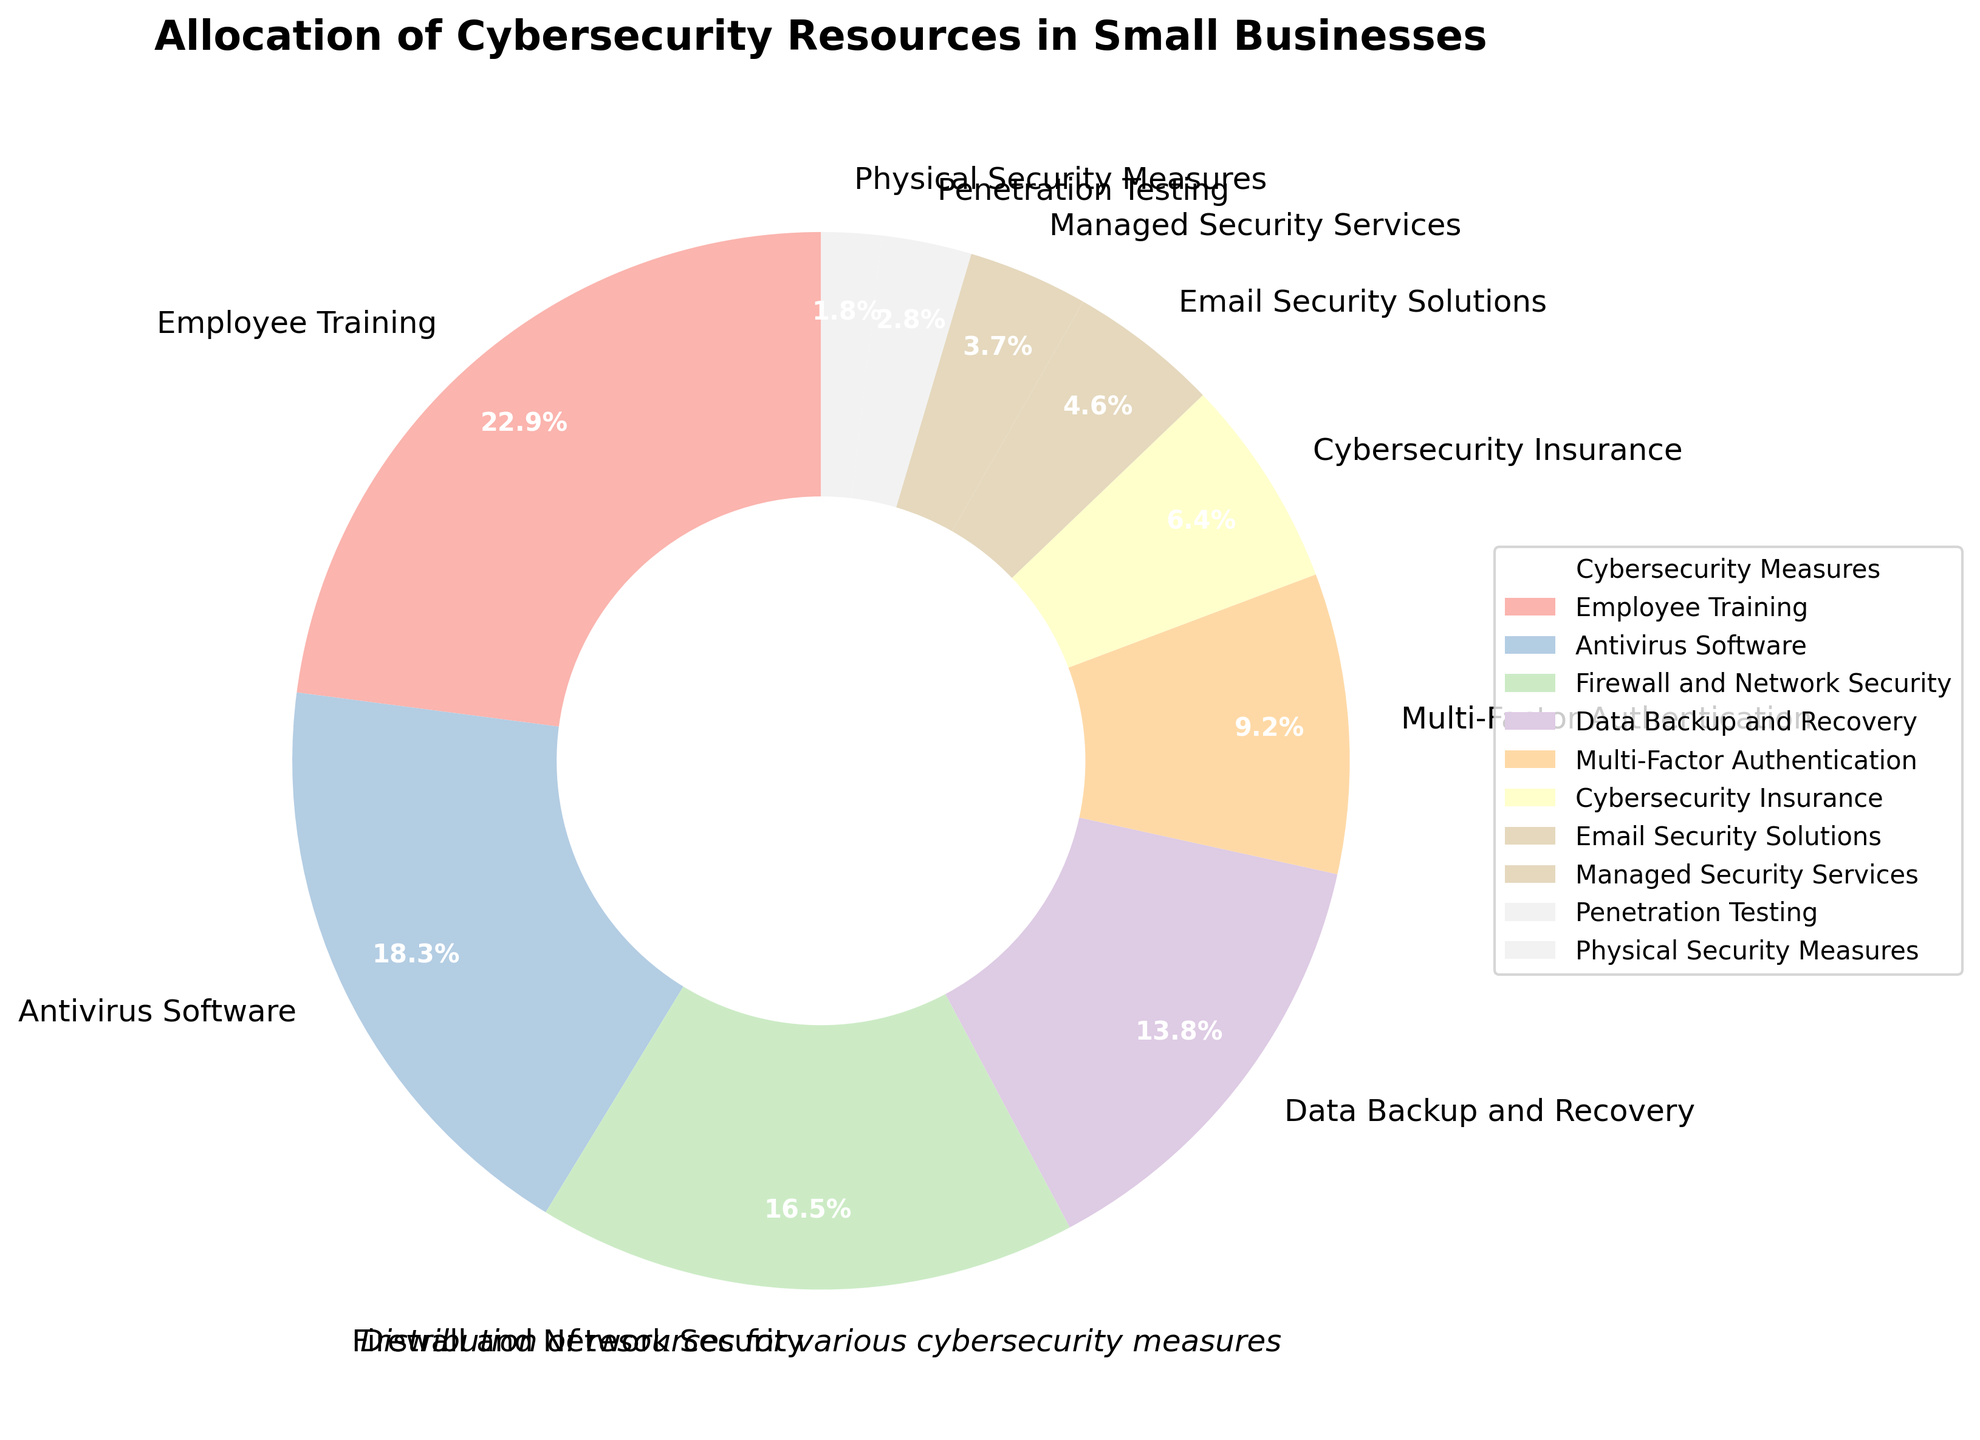What percentage of resources is allocated to Employee Training and Antivirus Software combined? Add the percentages for Employee Training (25%) and Antivirus Software (20%). The combined percentage is 25% + 20% = 45%.
Answer: 45% Which cybersecurity measure receives the least amount of resources? Penetration Testing (3%) receives fewer resources than other measures except for Physical Security Measures, which receives the least at 2%.
Answer: Physical Security Measures How much more percentage is allocated to Firewall and Network Security compared to Penetration Testing? Subtract the percentage for Penetration Testing (3%) from Firewall and Network Security (18%). The difference is 18% - 3% = 15%.
Answer: 15% What is the visual appearance of the segment representing Data Backup and Recovery in terms of size and placement? It is 15% of the pie chart and appears as a mid-sized wedge compared to the larger segments like Employee Training and Antivirus Software and smaller segments like Physical Security Measures.
Answer: Mid-sized wedge, 15% Which segment is visually the largest in the pie chart? Employee Training is the largest segment as it accounts for 25% of the pie chart, more than any other segment.
Answer: Employee Training How does the percentage allocation to Email Security Solutions compare to Multi-Factor Authentication? The percentage allocation to Email Security Solutions (5%) is less than that for Multi-Factor Authentication (10%).
Answer: Email Security Solutions < Multi-Factor Authentication What is the combined percentage for Multi-Factor Authentication, Cybersecurity Insurance, and Managed Security Services? Add the percentages for Multi-Factor Authentication (10%), Cybersecurity Insurance (7%), and Managed Security Services (4%). The combined percentage is 10% + 7% + 4% = 21%.
Answer: 21% What's the difference in allocation between the highest and lowest cybersecurity measures? The highest is Employee Training (25%), and the lowest is Physical Security Measures (2%). The difference is 25% - 2% = 23%.
Answer: 23% If you add the percentages for Firewall and Network Security and Data Backup and Recovery, how does the result compare to the percentage for Employee Training? Add the percentages for Firewall and Network Security (18%) and Data Backup and Recovery (15%). The combined percentage is 18% + 15% = 33%, which is higher than Employee Training's 25%.
Answer: Firewall and Network Security + Data Backup and Recovery > Employee Training Which segment has a color different from the others in terms of hue and what is the hue? The pie chart uses a pastel color palette where each segment has a distinct pastel hue. However, since the question is about identifying a unique segment in terms of color, it's subjective without seeing the chart. The answer would depend on visual inspection.
Answer: Distinct pastel hue 